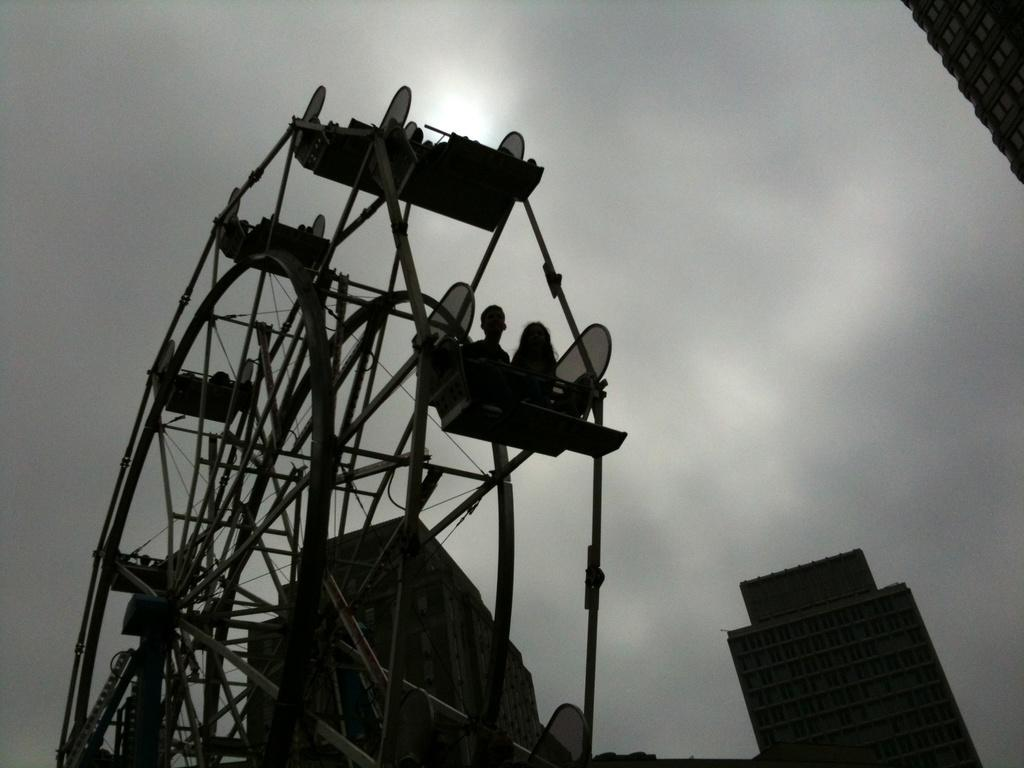What are the people in the image doing? The people in the image are sitting in a Ferris wheel. What can be seen in the background of the image? There are buildings visible in the background. What is visible in the sky in the image? The sky is visible in the image. How would you describe the weather based on the appearance of the sky? The sky appears to be cloudy in the image. What type of secretary can be seen working in the image? There is no secretary present in the image; it features people sitting in a Ferris wheel with buildings and a cloudy sky in the background. 